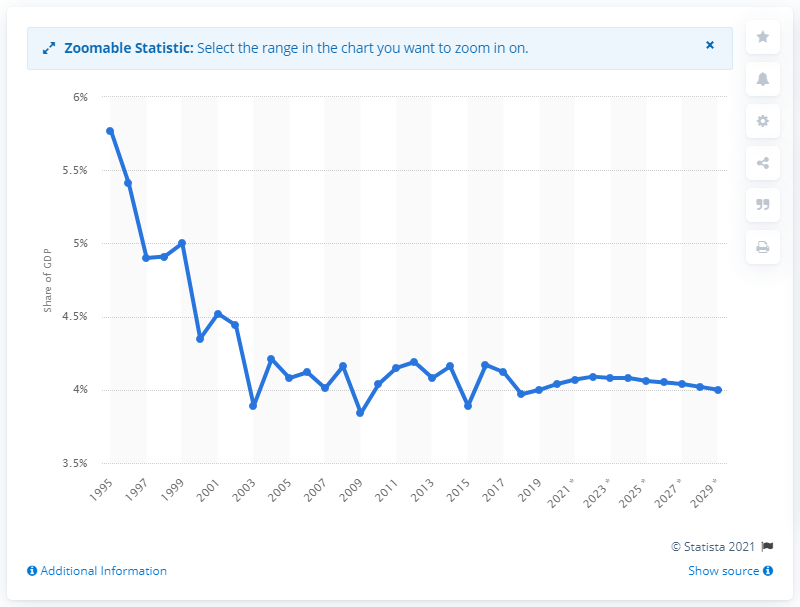Give some essential details in this illustration. Singapore's forecast for the contribution of tourism to increase to in 2020 is expected to be 4%. 